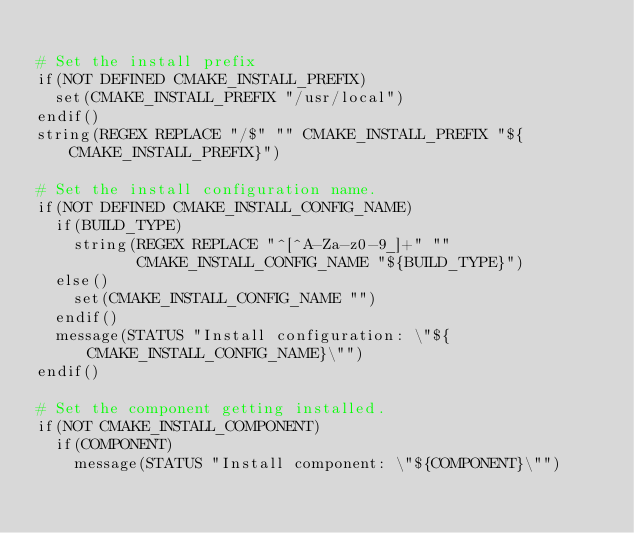<code> <loc_0><loc_0><loc_500><loc_500><_CMake_>
# Set the install prefix
if(NOT DEFINED CMAKE_INSTALL_PREFIX)
  set(CMAKE_INSTALL_PREFIX "/usr/local")
endif()
string(REGEX REPLACE "/$" "" CMAKE_INSTALL_PREFIX "${CMAKE_INSTALL_PREFIX}")

# Set the install configuration name.
if(NOT DEFINED CMAKE_INSTALL_CONFIG_NAME)
  if(BUILD_TYPE)
    string(REGEX REPLACE "^[^A-Za-z0-9_]+" ""
           CMAKE_INSTALL_CONFIG_NAME "${BUILD_TYPE}")
  else()
    set(CMAKE_INSTALL_CONFIG_NAME "")
  endif()
  message(STATUS "Install configuration: \"${CMAKE_INSTALL_CONFIG_NAME}\"")
endif()

# Set the component getting installed.
if(NOT CMAKE_INSTALL_COMPONENT)
  if(COMPONENT)
    message(STATUS "Install component: \"${COMPONENT}\"")</code> 